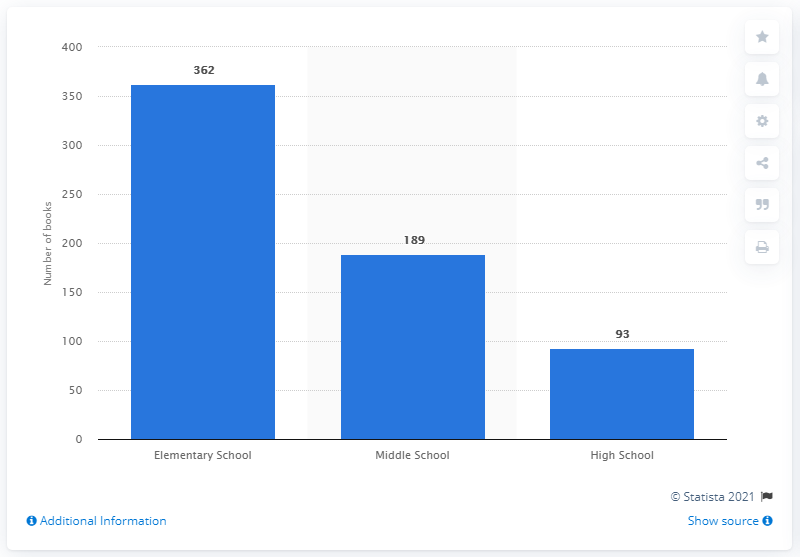Outline some significant characteristics in this image. In 2016, the average number of books possessed by elementary school teachers in their classrooms was 362, according to a recent study. 